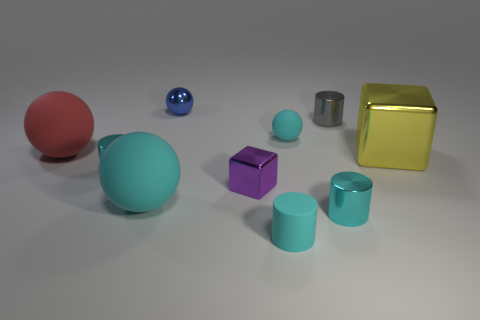There is another metallic object that is the same shape as the red thing; what is its size?
Your answer should be compact. Small. What number of big red balls have the same material as the yellow thing?
Offer a terse response. 0. Are there fewer tiny blue shiny things that are on the right side of the large cube than blue balls?
Make the answer very short. Yes. What number of gray cylinders are there?
Offer a very short reply. 1. What number of large rubber spheres have the same color as the small rubber cylinder?
Your answer should be compact. 1. Is the shape of the red rubber object the same as the blue metal thing?
Your answer should be compact. Yes. There is a cyan matte sphere that is in front of the cyan cylinder that is to the left of the purple block; how big is it?
Give a very brief answer. Large. Is there a red cube of the same size as the gray thing?
Provide a succinct answer. No. There is a ball in front of the red matte ball; is it the same size as the metallic object that is to the right of the tiny gray metallic object?
Give a very brief answer. Yes. There is a small cyan rubber thing in front of the big yellow block that is to the right of the tiny blue metallic sphere; what is its shape?
Offer a terse response. Cylinder. 